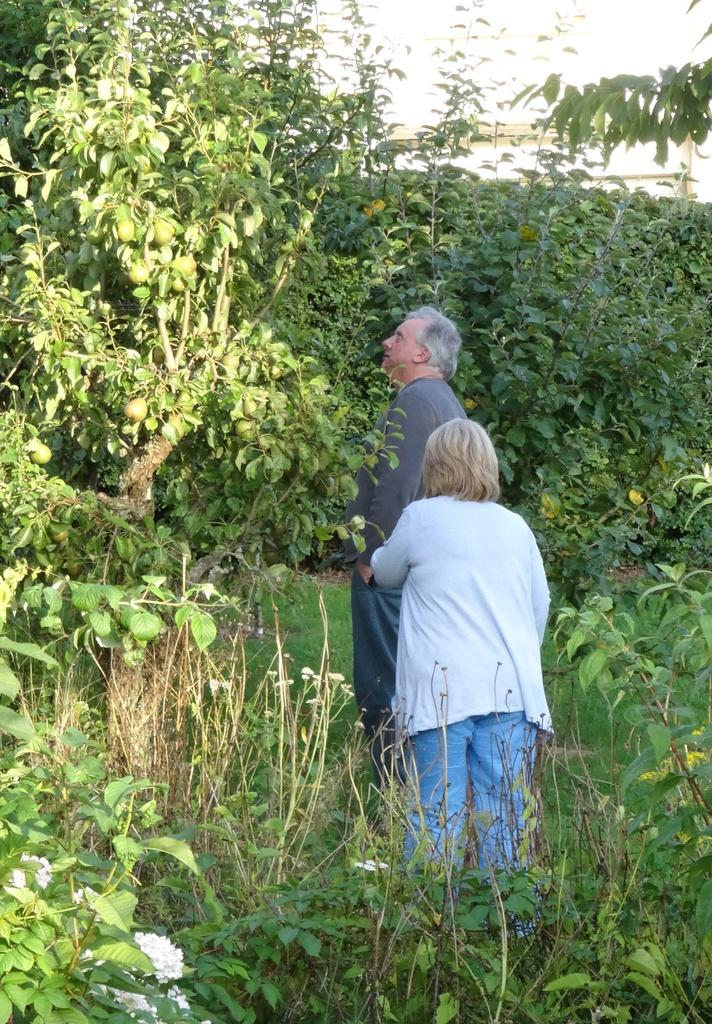How many people are in the image? There are two people in the center of the image. What can be seen in the background of the image? There are trees in the background of the image. What is located at the bottom of the image? There are plants at the bottom of the image. What color is the paint on the geese in the image? There are no geese or paint present in the image. 